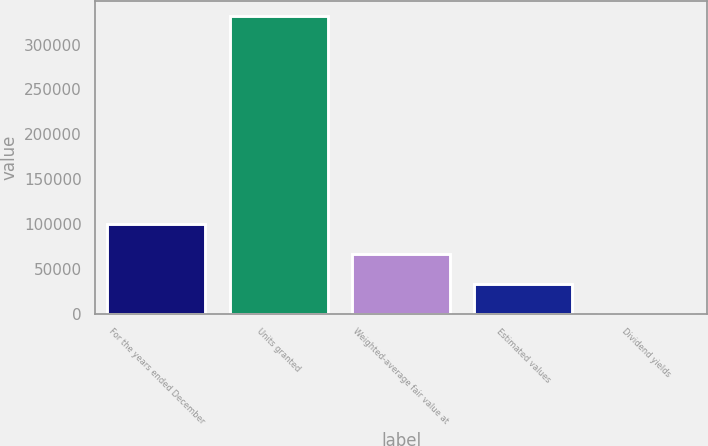Convert chart to OTSL. <chart><loc_0><loc_0><loc_500><loc_500><bar_chart><fcel>For the years ended December<fcel>Units granted<fcel>Weighted-average fair value at<fcel>Estimated values<fcel>Dividend yields<nl><fcel>99537.7<fcel>331788<fcel>66359<fcel>33180.4<fcel>1.8<nl></chart> 